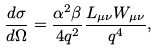Convert formula to latex. <formula><loc_0><loc_0><loc_500><loc_500>\frac { d \sigma } { d \Omega } = \frac { \alpha ^ { 2 } \beta } { 4 q ^ { 2 } } \frac { L _ { \mu \nu } W _ { \mu \nu } } { q ^ { 4 } } ,</formula> 